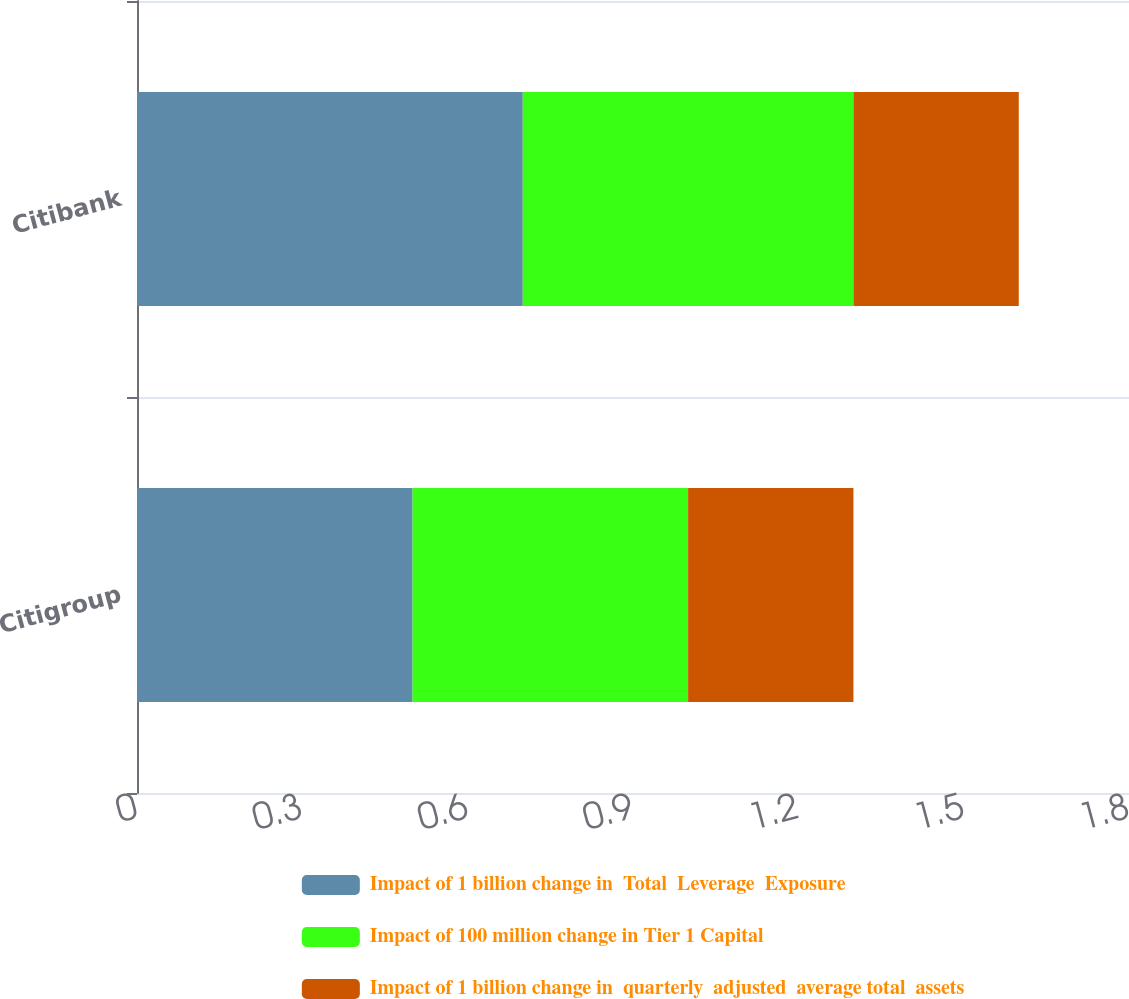Convert chart to OTSL. <chart><loc_0><loc_0><loc_500><loc_500><stacked_bar_chart><ecel><fcel>Citigroup<fcel>Citibank<nl><fcel>Impact of 1 billion change in  Total  Leverage  Exposure<fcel>0.5<fcel>0.7<nl><fcel>Impact of 100 million change in Tier 1 Capital<fcel>0.5<fcel>0.6<nl><fcel>Impact of 1 billion change in  quarterly  adjusted  average total  assets<fcel>0.3<fcel>0.3<nl></chart> 